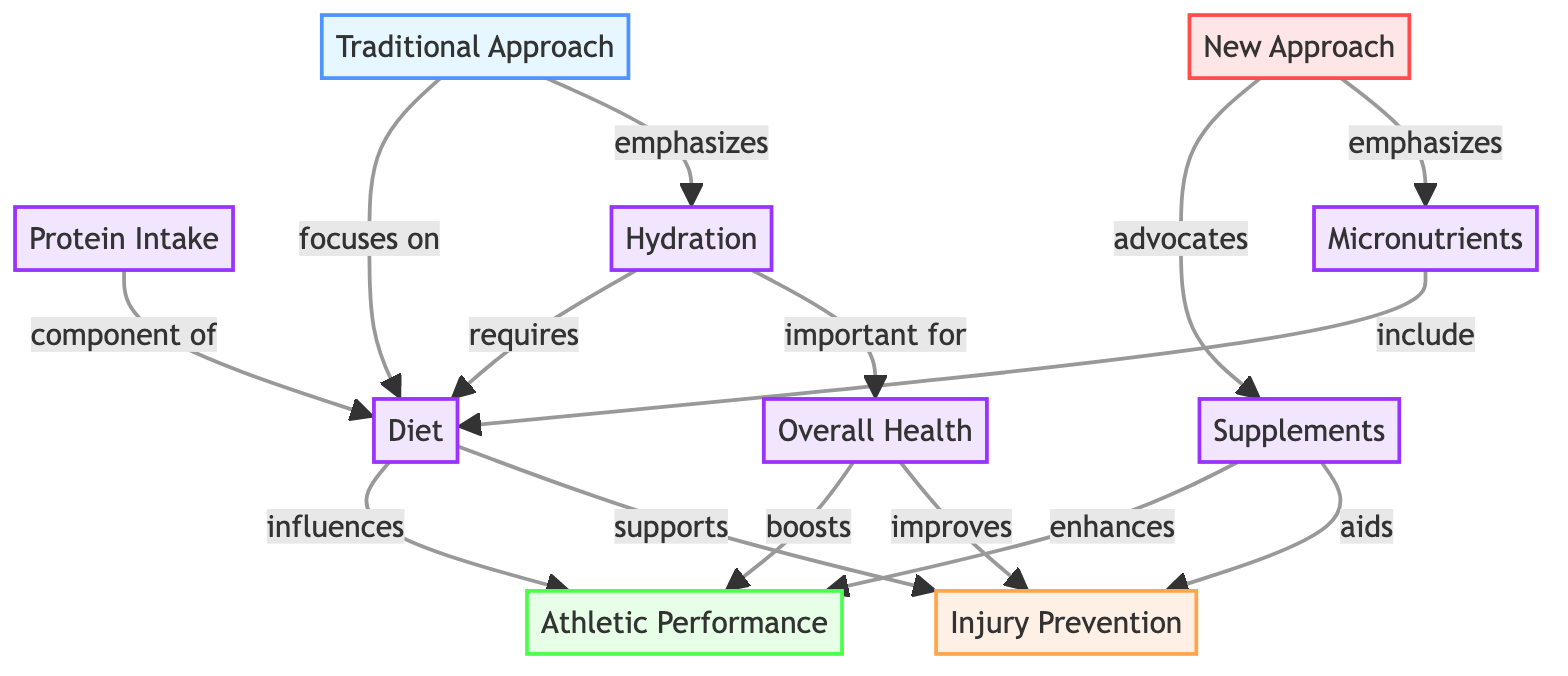What are the two main outcomes of focus in this diagram? The diagram highlights two main outcomes: Athletic Performance and Injury Prevention. These are clearly identified at the top of the diagram as nodes.
Answer: Athletic Performance, Injury Prevention How many nodes represent aspects of nutrition in the diagram? There are five nodes related to nutrition: Diet, Supplements, Protein Intake, Micronutrients, and Hydration. Counting these nodes gives us the total.
Answer: 5 What influences Athletic Performance according to the diagram? The nodes listed as influences on Athletic Performance include Diet and Supplements. The diagram directly indicates these relationships.
Answer: Diet, Supplements Which approach emphasizes Micronutrients? The New Approach is the one that emphasizes Micronutrients as indicated by the connecting edge. This is distinct from the Traditional Approach, which focuses differently.
Answer: New Approach Which factor is important for both Overall Health and Injury Prevention? Overall Health is indicated in the diagram to improve Injury Prevention, and it is also linked to several nutrition nodes, signifying its importance.
Answer: Overall Health What does the Traditional Approach focus on? The diagram specifies that the Traditional Approach focuses on Diet and emphasizes Hydration, which are the nodes directly linked to it.
Answer: Diet, Hydration What assists in enhancing Athletic Performance according to the New Approach? The New Approach advocates Supplements as a key factor in enhancing Athletic Performance, as shown through the relationship depicted in the diagram.
Answer: Supplements How does Hydration relate to Overall Health? The diagram shows that Hydration is required by Diet, which is also linked to Overall Health. Thus, Hydration is important for Overall Health.
Answer: Important for Overall Health 